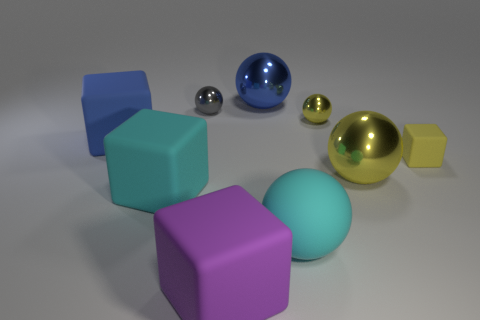What material is the tiny sphere that is the same color as the small matte block?
Ensure brevity in your answer.  Metal. What number of blue metallic spheres are there?
Provide a succinct answer. 1. What material is the block that is on the right side of the blue metal ball behind the small rubber thing?
Your answer should be very brief. Rubber. What material is the blue sphere that is the same size as the cyan ball?
Ensure brevity in your answer.  Metal. Do the cyan object that is behind the cyan rubber ball and the big matte ball have the same size?
Ensure brevity in your answer.  Yes. There is a large cyan matte thing to the left of the big purple matte block; is its shape the same as the yellow matte object?
Make the answer very short. Yes. What number of things are tiny matte blocks or yellow metallic objects behind the blue matte thing?
Your answer should be very brief. 2. Is the number of large yellow objects less than the number of large metal things?
Ensure brevity in your answer.  Yes. Are there more big red objects than small yellow rubber objects?
Give a very brief answer. No. What number of other objects are the same material as the cyan ball?
Your answer should be compact. 4. 